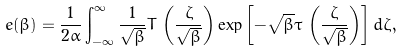<formula> <loc_0><loc_0><loc_500><loc_500>e ( \beta ) = \frac { 1 } { 2 \alpha } \int _ { - \infty } ^ { \infty } \frac { 1 } { \sqrt { \beta } } T \, \left ( \frac { \zeta } { \sqrt { \beta } } \right ) \exp \left [ - \sqrt { \beta } \tau \, \left ( \frac { \zeta } { \sqrt { \beta } } \right ) \right ] d \zeta ,</formula> 